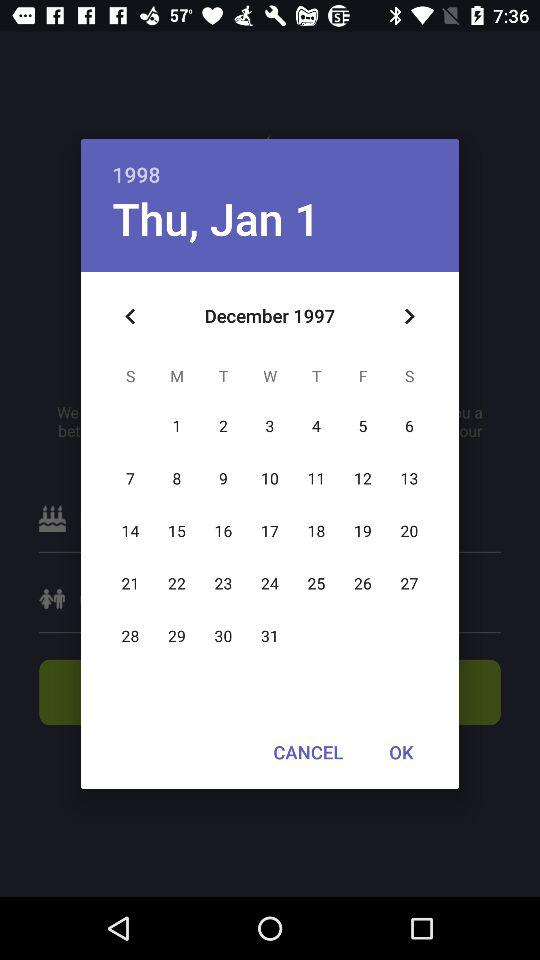What's the selected date? The selected date is Thursday, January 1, 1998. 